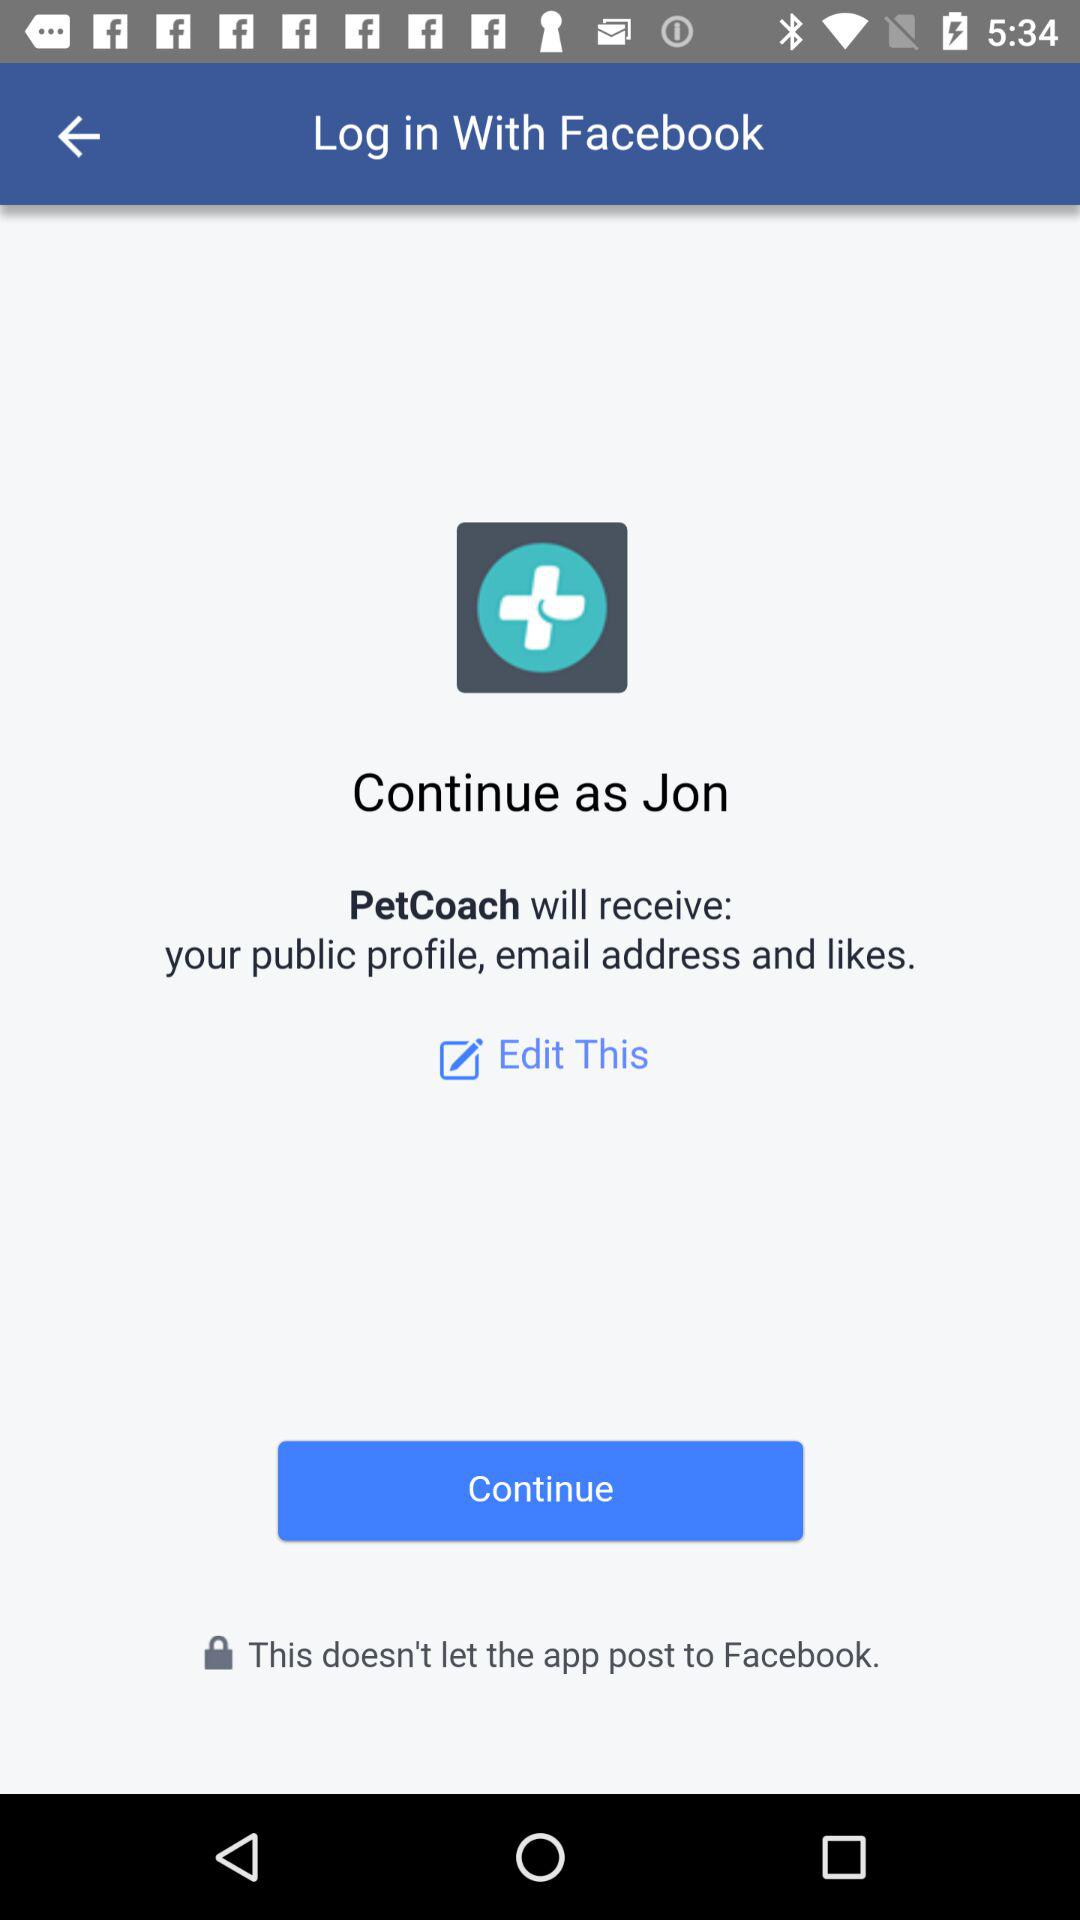What application is asking for permission? The application asking for permission is "PetCoach". 